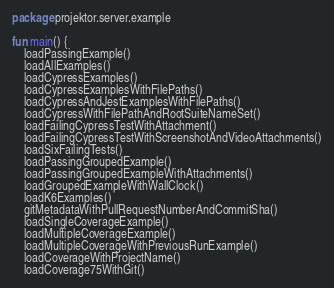<code> <loc_0><loc_0><loc_500><loc_500><_Kotlin_>package projektor.server.example

fun main() {
    loadPassingExample()
    loadAllExamples()
    loadCypressExamples()
    loadCypressExamplesWithFilePaths()
    loadCypressAndJestExamplesWithFilePaths()
    loadCypressWithFilePathAndRootSuiteNameSet()
    loadFailingCypressTestWithAttachment()
    loadFailingCypressTestWithScreenshotAndVideoAttachments()
    loadSixFailingTests()
    loadPassingGroupedExample()
    loadPassingGroupedExampleWithAttachments()
    loadGroupedExampleWithWallClock()
    loadK6Examples()
    gitMetadataWithPullRequestNumberAndCommitSha()
    loadSingleCoverageExample()
    loadMultipleCoverageExample()
    loadMultipleCoverageWithPreviousRunExample()
    loadCoverageWithProjectName()
    loadCoverage75WithGit()</code> 